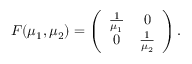<formula> <loc_0><loc_0><loc_500><loc_500>\begin{array} { r } { F ( \mu _ { 1 } , \mu _ { 2 } ) = \left ( \begin{array} { c c } { \frac { 1 } \mu _ { 1 } } } & { 0 } \\ { 0 } & { \frac { 1 } \mu _ { 2 } } } \end{array} \right ) . } \end{array}</formula> 